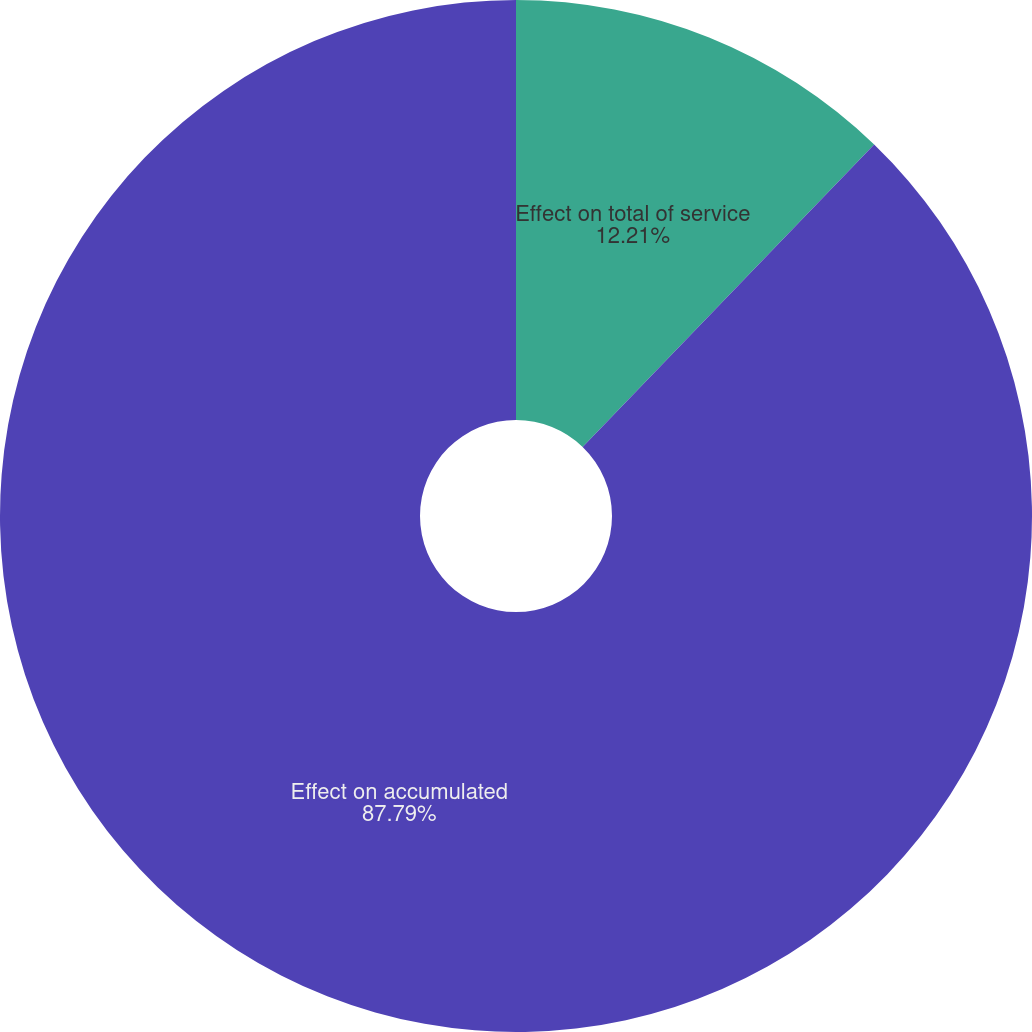<chart> <loc_0><loc_0><loc_500><loc_500><pie_chart><fcel>Effect on total of service<fcel>Effect on accumulated<nl><fcel>12.21%<fcel>87.79%<nl></chart> 